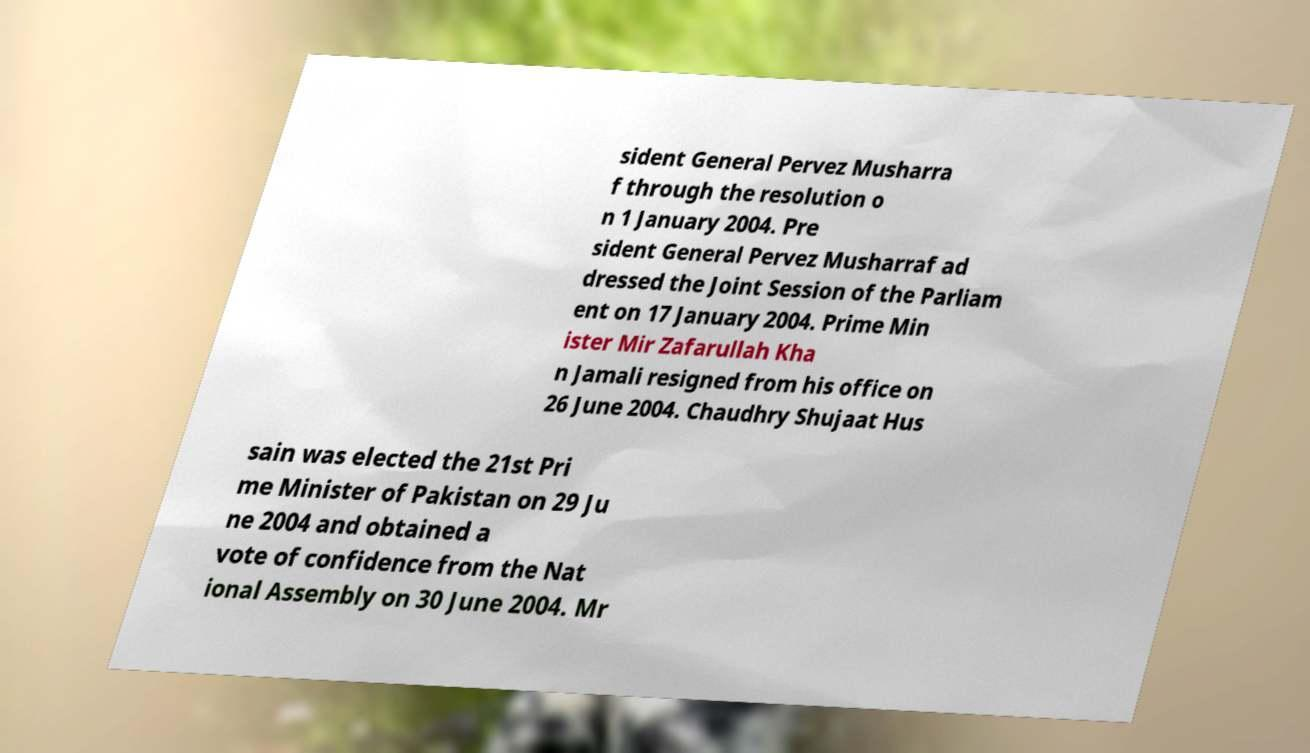Please identify and transcribe the text found in this image. sident General Pervez Musharra f through the resolution o n 1 January 2004. Pre sident General Pervez Musharraf ad dressed the Joint Session of the Parliam ent on 17 January 2004. Prime Min ister Mir Zafarullah Kha n Jamali resigned from his office on 26 June 2004. Chaudhry Shujaat Hus sain was elected the 21st Pri me Minister of Pakistan on 29 Ju ne 2004 and obtained a vote of confidence from the Nat ional Assembly on 30 June 2004. Mr 